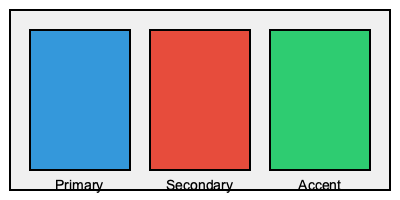Which color theory principle is most important when selecting the primary, secondary, and accent colors for an Android app interface to ensure optimal user experience? To create an effective color scheme for an Android app interface, consider the following steps:

1. Understand color theory principles:
   - Complementary colors: Colors opposite on the color wheel
   - Analogous colors: Colors adjacent on the color wheel
   - Triadic colors: Three evenly spaced colors on the color wheel
   - Monochromatic colors: Various shades and tints of a single color

2. Consider the importance of contrast:
   - High contrast between text and background improves readability
   - Contrast helps distinguish between different UI elements

3. Apply the 60-30-10 rule:
   - 60% dominant color (primary)
   - 30% secondary color
   - 10% accent color

4. Ensure accessibility:
   - Use colors that are distinguishable for color-blind users
   - Maintain sufficient contrast ratios for text legibility

5. Align with brand identity:
   - Use colors that reflect the app's purpose and brand

6. Consider cultural implications:
   - Colors can have different meanings in various cultures

Among these principles, contrast is the most crucial for optimal user experience in Android app interfaces. High contrast ensures readability, helps users distinguish between different UI elements, and improves overall usability. It's essential for creating a clear visual hierarchy and guiding users through the interface effectively.
Answer: Contrast 